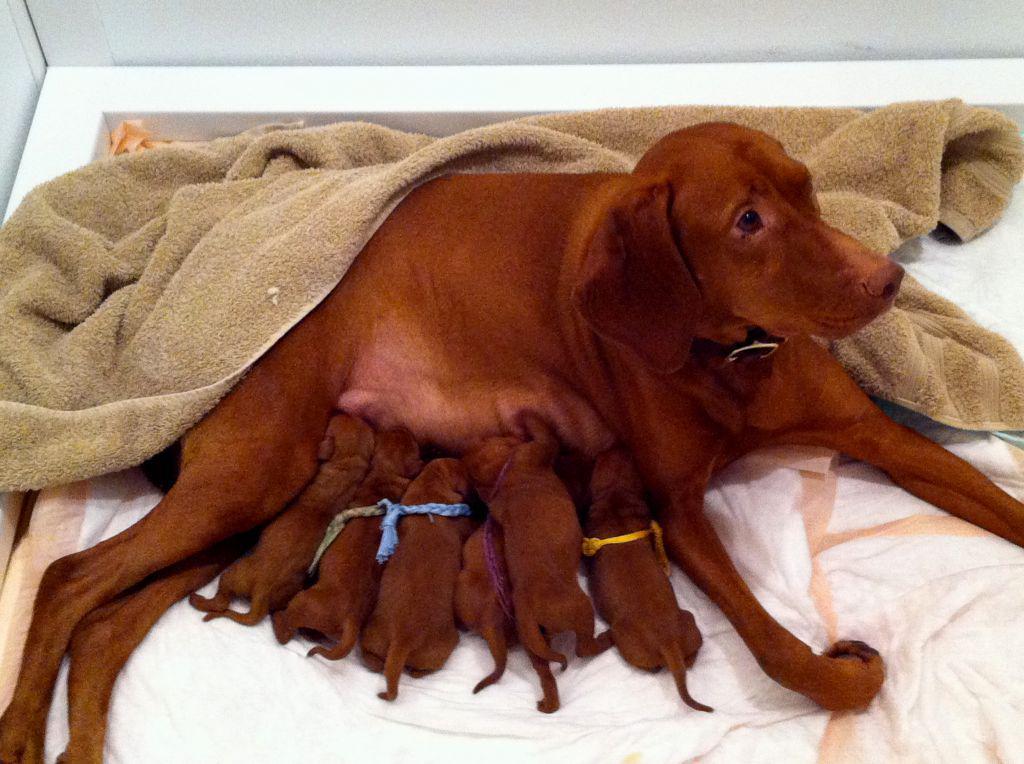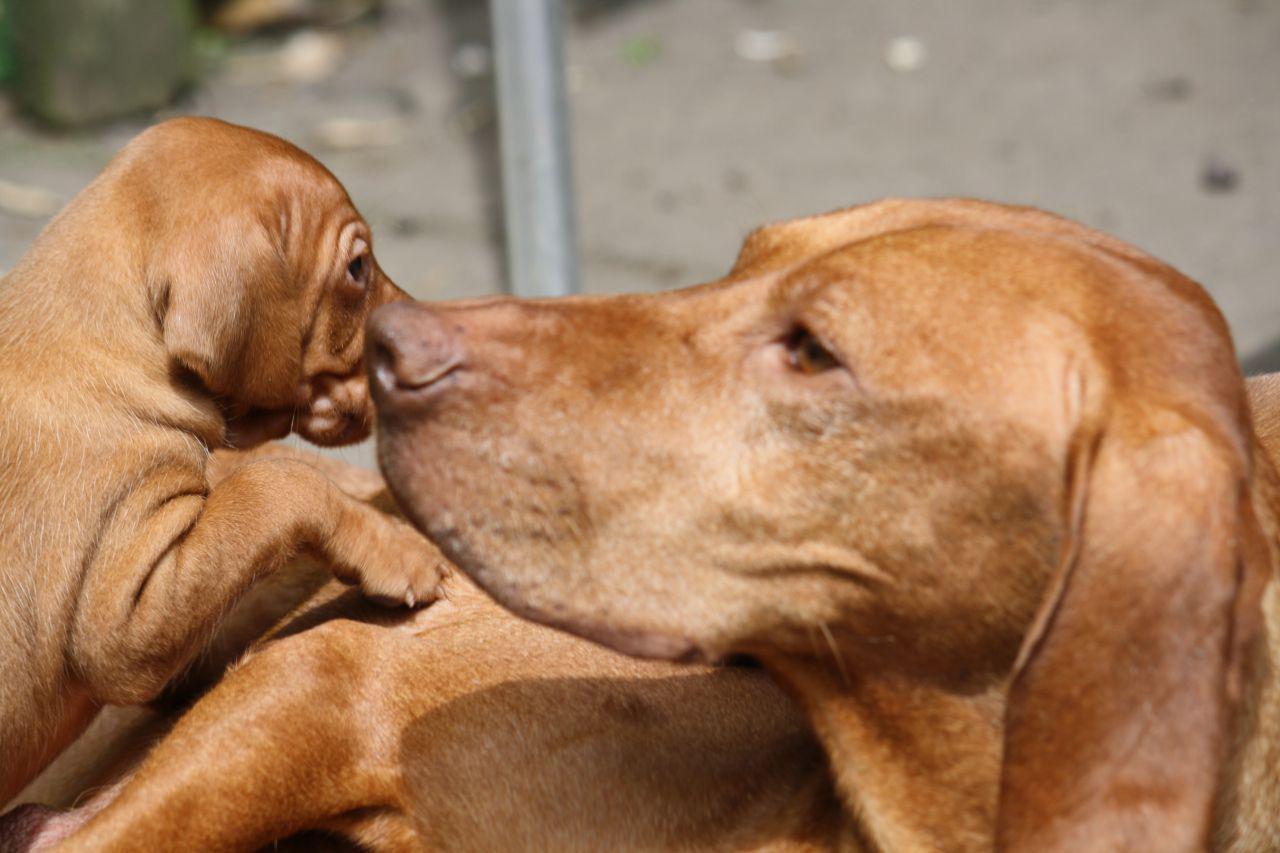The first image is the image on the left, the second image is the image on the right. Examine the images to the left and right. Is the description "There are exactly two dogs." accurate? Answer yes or no. No. The first image is the image on the left, the second image is the image on the right. For the images displayed, is the sentence "One dog faces straight ahead, at least one dog is wearing a blue collar, and at least two dogs are wearing collars." factually correct? Answer yes or no. No. 